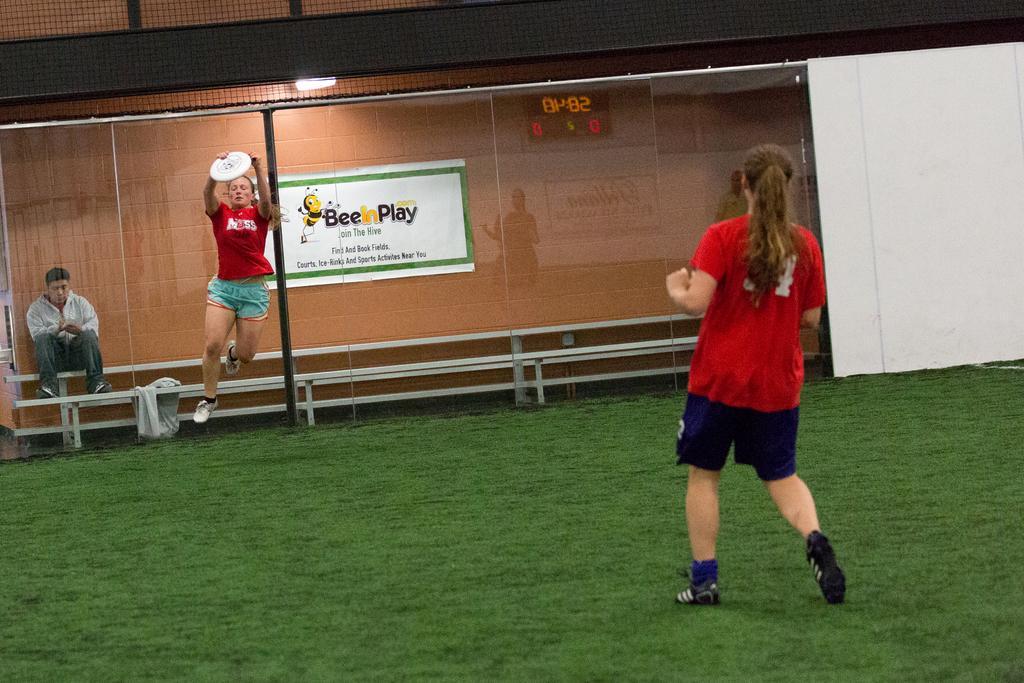Could you give a brief overview of what you see in this image? This woman is in the air and holding a disc. Banner is on the wall. On this glass there is a reflection of digital scoreboard. This person is sitting on a bench. Front this woman is standing on grass.  